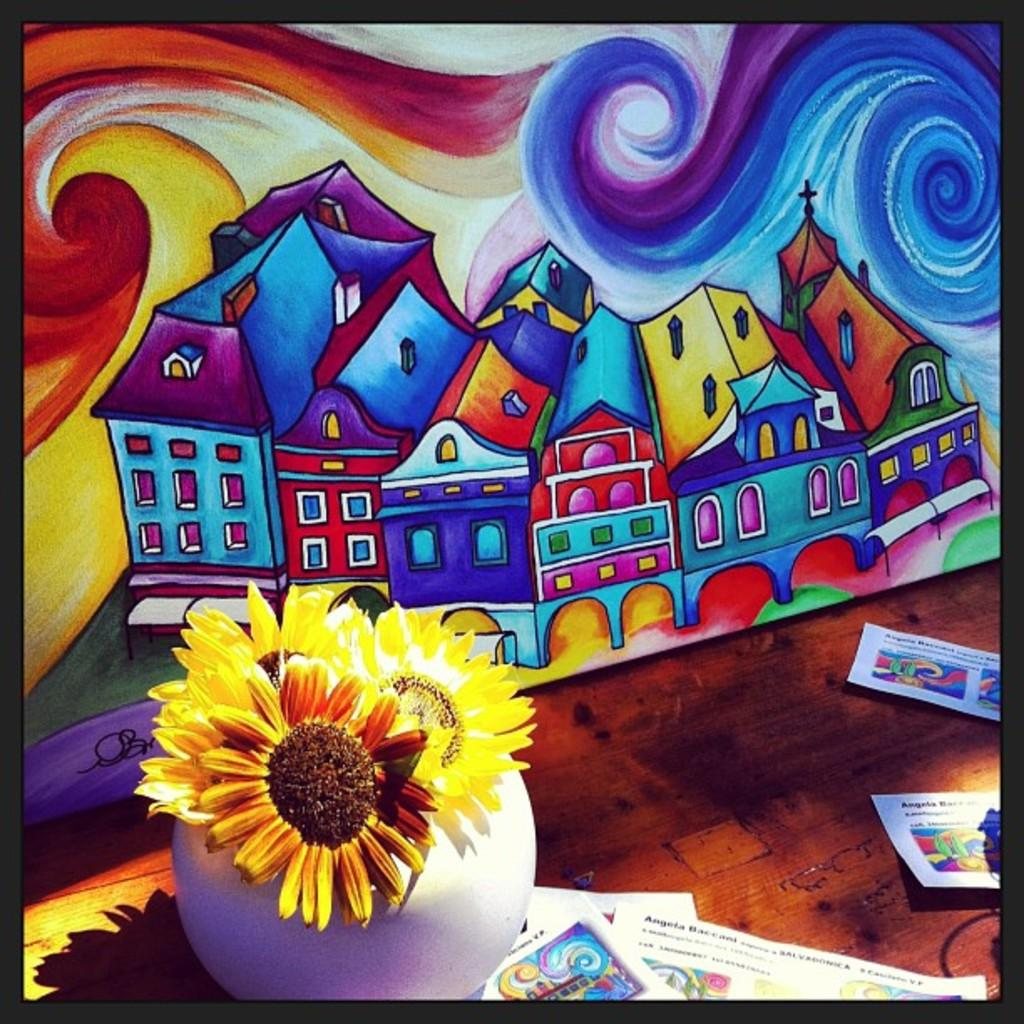What is hanging on the wall in the image? There is a painting on the wall in the image. What piece of furniture is present in the image? There is a table in the image. What is on the table in the image? There is a flower vase and papers on the table. Can you see any honey dripping from the painting in the image? There is no honey present in the image, and the painting is not depicted as dripping anything. What type of ocean is visible in the image? There is no ocean present in the image; it features a painting on the wall, a table, a flower vase, and papers. 